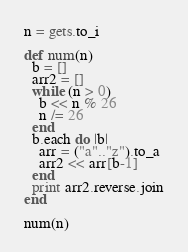<code> <loc_0><loc_0><loc_500><loc_500><_Ruby_>n = gets.to_i

def num(n)
  b = []
  arr2 = []
  while (n > 0)
    b << n % 26
    n /= 26
  end
  b.each do |b|
    arr = ("a".."z").to_a
    arr2 << arr[b-1]
  end
  print arr2.reverse.join
end

num(n)</code> 